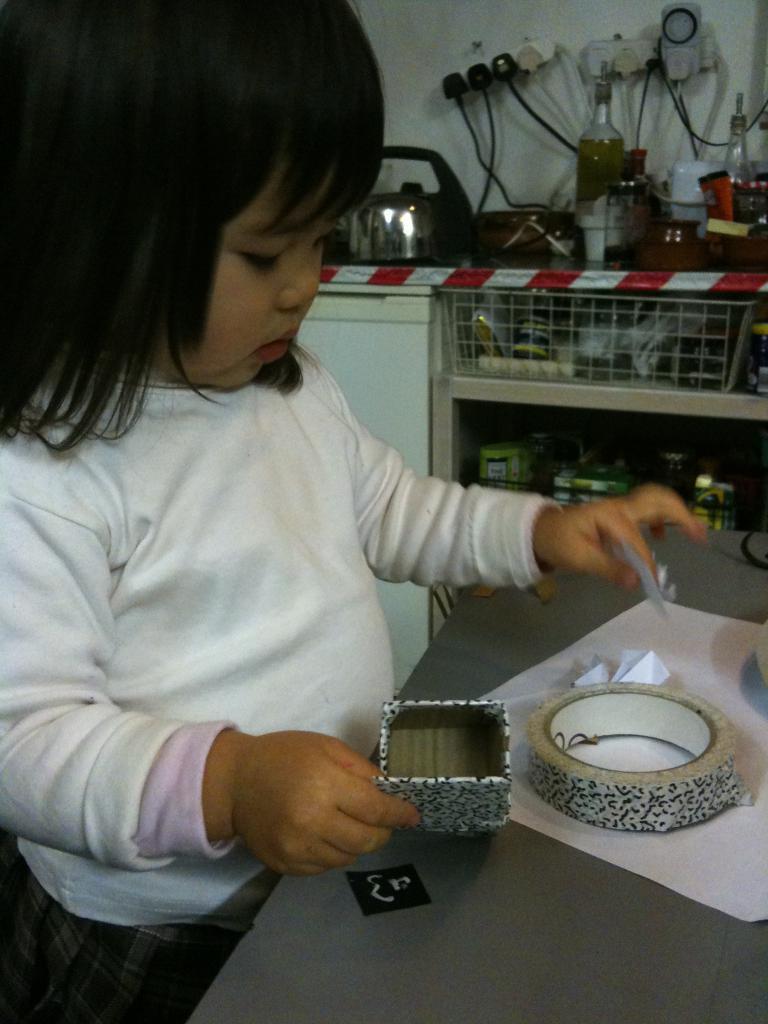Could you give a brief overview of what you see in this image? On the left side of the image we can see a girl, she is holding a box, in front of her we can see a plaster, papers and other things on the table, in the background we can see few bottles, sockets, cables and other things on the countertop. 